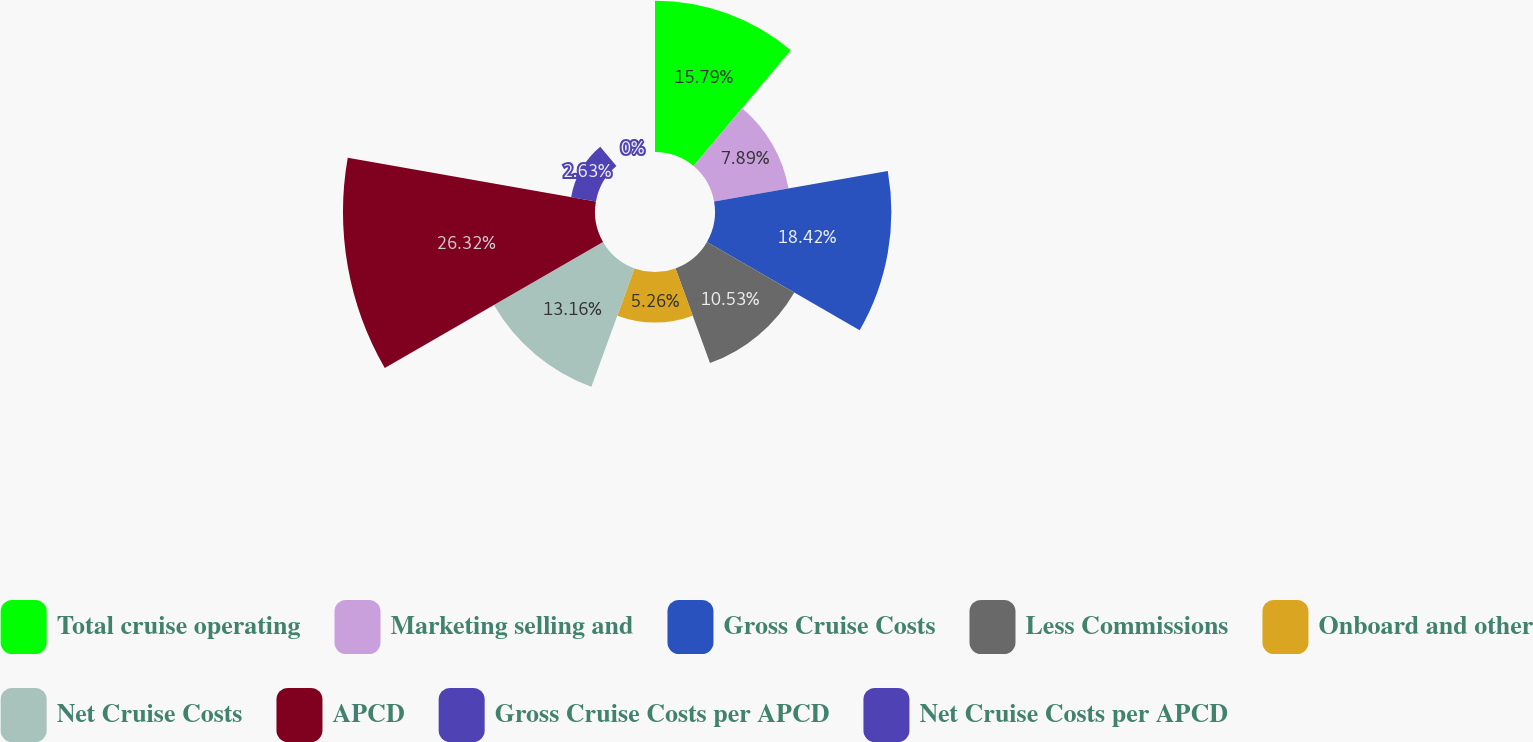Convert chart. <chart><loc_0><loc_0><loc_500><loc_500><pie_chart><fcel>Total cruise operating<fcel>Marketing selling and<fcel>Gross Cruise Costs<fcel>Less Commissions<fcel>Onboard and other<fcel>Net Cruise Costs<fcel>APCD<fcel>Gross Cruise Costs per APCD<fcel>Net Cruise Costs per APCD<nl><fcel>15.79%<fcel>7.89%<fcel>18.42%<fcel>10.53%<fcel>5.26%<fcel>13.16%<fcel>26.32%<fcel>2.63%<fcel>0.0%<nl></chart> 